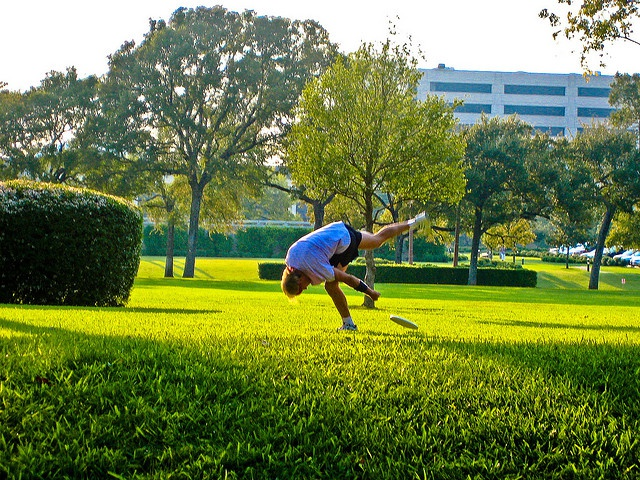Describe the objects in this image and their specific colors. I can see people in white, black, maroon, olive, and gray tones, car in white, black, lightblue, and teal tones, frisbee in white, olive, gray, and lightgreen tones, car in white, navy, lightblue, and black tones, and car in white, lightblue, black, and gray tones in this image. 